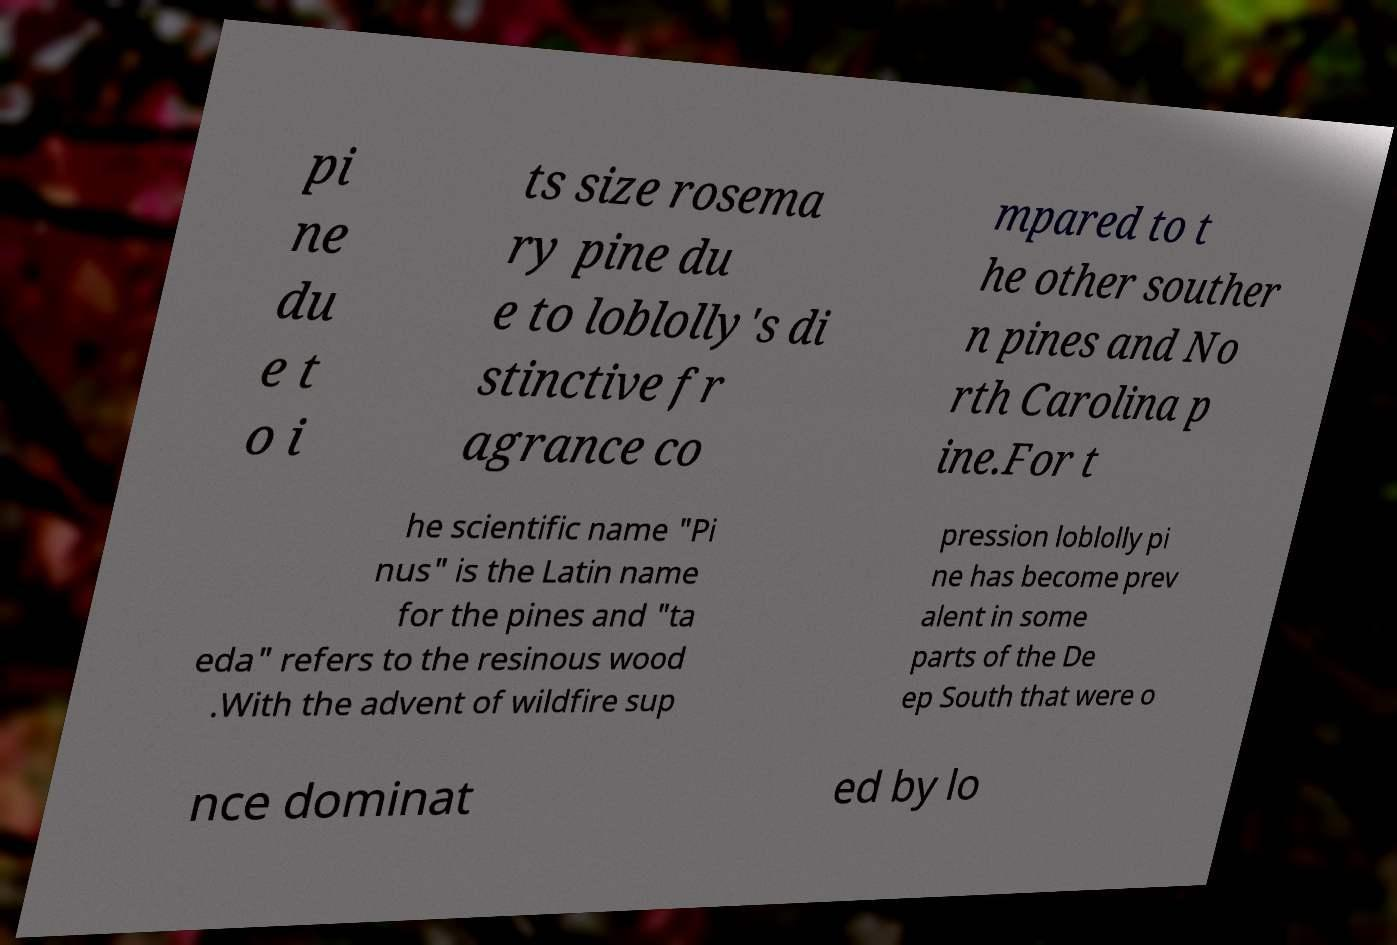Please read and relay the text visible in this image. What does it say? pi ne du e t o i ts size rosema ry pine du e to loblolly's di stinctive fr agrance co mpared to t he other souther n pines and No rth Carolina p ine.For t he scientific name "Pi nus" is the Latin name for the pines and "ta eda" refers to the resinous wood .With the advent of wildfire sup pression loblolly pi ne has become prev alent in some parts of the De ep South that were o nce dominat ed by lo 